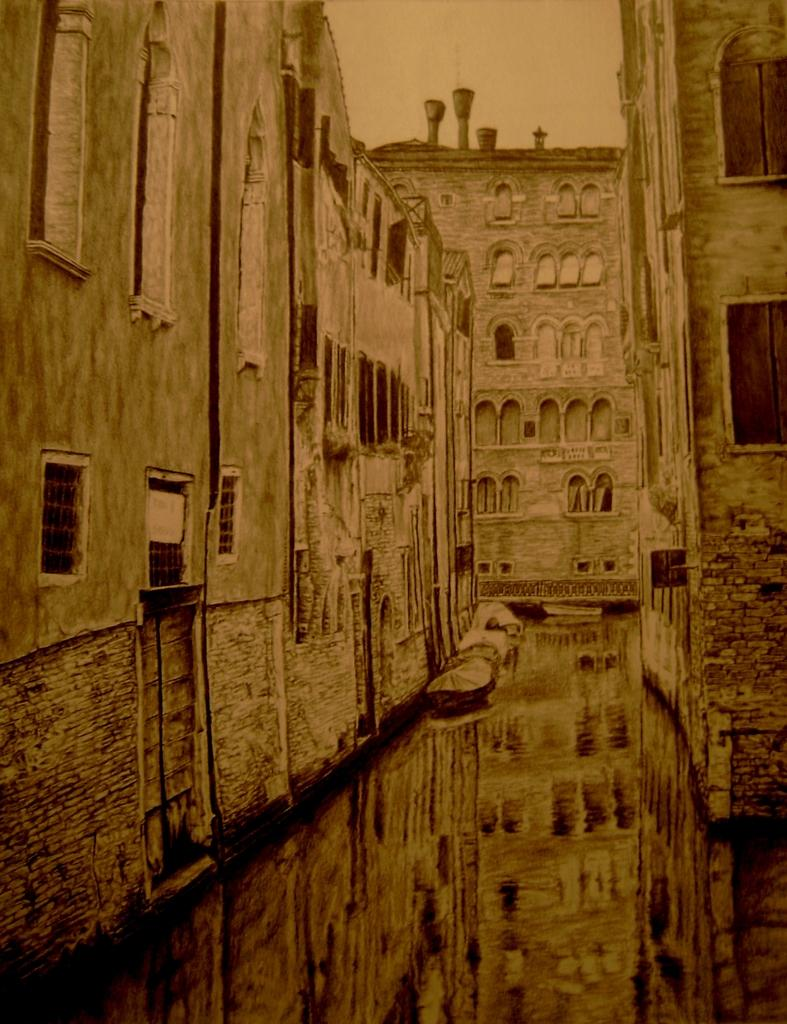What type of structures are present in the image? There are buildings in the image. What features can be seen on the buildings? The buildings have windows, doors, and ventilators. What is visible at the top of the image? The sky is visible at the top of the image. What is present on the ground at the bottom of the image? There is water on the ground at the bottom of the image. What language is spoken by the bears in the image? There are no bears present in the image, so it is not applicable language cannot be determined. 